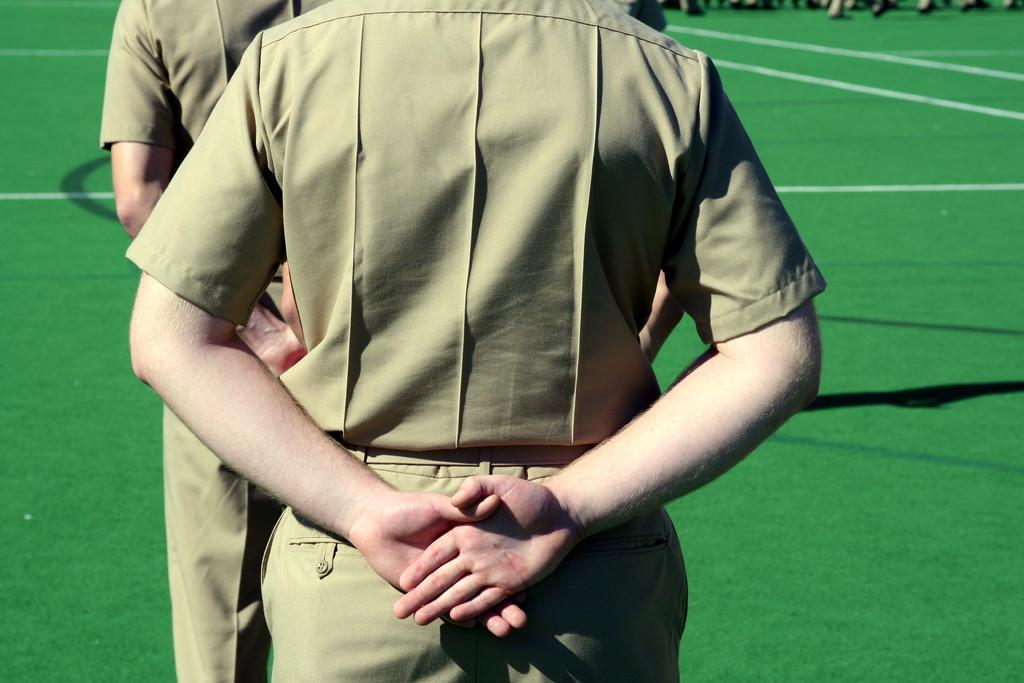What are the persons in the image wearing? The persons in the image are wearing uniforms. What type of surface is visible on the ground in the image? There is grass on the ground in the image. How many spiders are crawling on the side of the persons in the image? There are no spiders visible in the image. What does the grandfather say about the uniforms in the image? There is no mention of a grandfather in the image or the provided facts. 